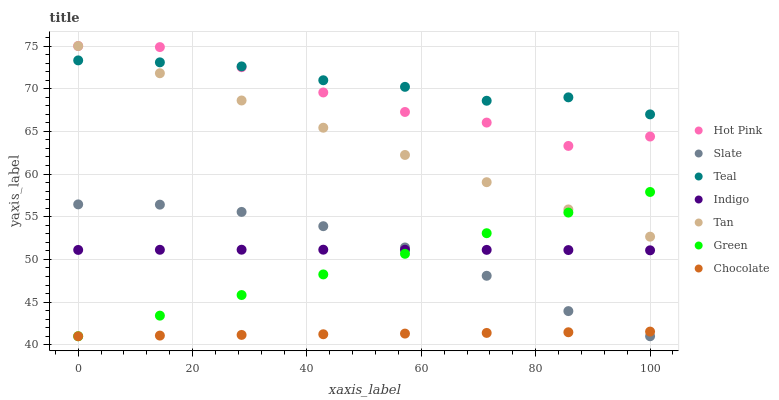Does Chocolate have the minimum area under the curve?
Answer yes or no. Yes. Does Teal have the maximum area under the curve?
Answer yes or no. Yes. Does Slate have the minimum area under the curve?
Answer yes or no. No. Does Slate have the maximum area under the curve?
Answer yes or no. No. Is Green the smoothest?
Answer yes or no. Yes. Is Hot Pink the roughest?
Answer yes or no. Yes. Is Slate the smoothest?
Answer yes or no. No. Is Slate the roughest?
Answer yes or no. No. Does Slate have the lowest value?
Answer yes or no. Yes. Does Hot Pink have the lowest value?
Answer yes or no. No. Does Tan have the highest value?
Answer yes or no. Yes. Does Slate have the highest value?
Answer yes or no. No. Is Green less than Teal?
Answer yes or no. Yes. Is Hot Pink greater than Indigo?
Answer yes or no. Yes. Does Indigo intersect Green?
Answer yes or no. Yes. Is Indigo less than Green?
Answer yes or no. No. Is Indigo greater than Green?
Answer yes or no. No. Does Green intersect Teal?
Answer yes or no. No. 